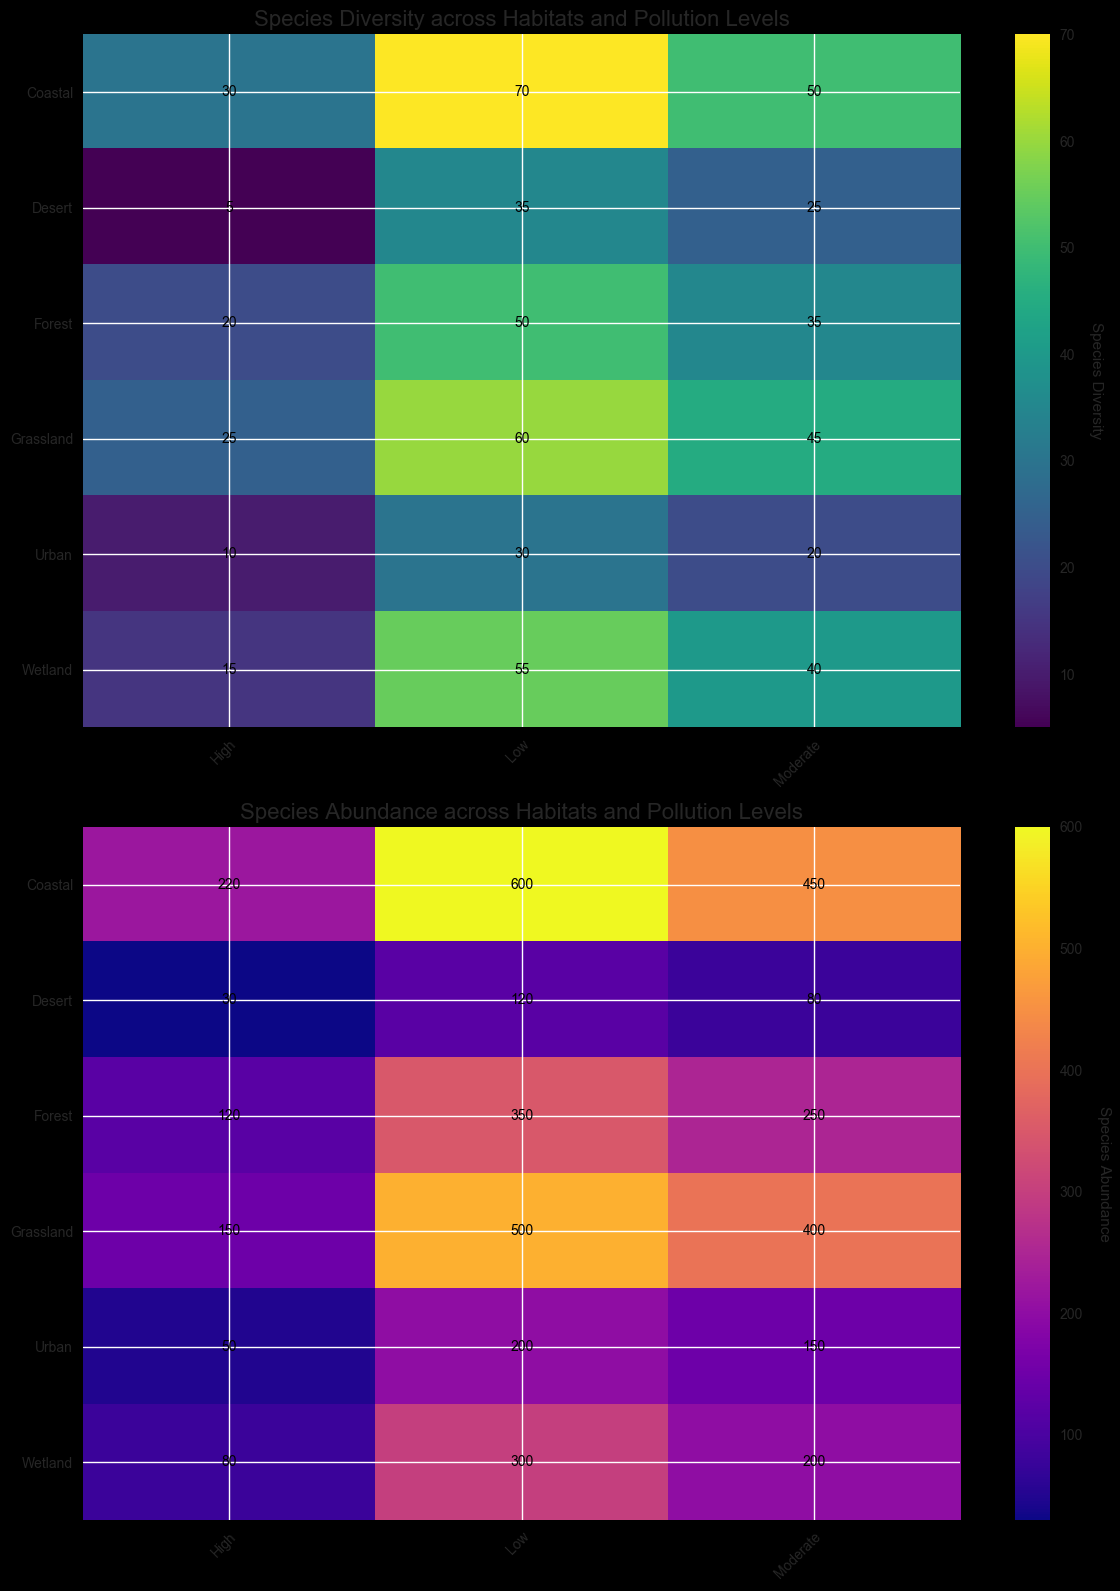What habitat has the highest species diversity at low pollution levels? Look at the first heatmap for species diversity, focusing on columns labeled 'Low'. The row labeled 'Coastal' has the darkest shade, indicating the highest number.
Answer: Coastal Which habitat shows the greatest decrease in species diversity from low to high pollution levels? Observe the difference in species diversity values from the 'Low' to 'High' columns. 'Desert' decreases from 35 to 5, a drop of 30.
Answer: Desert Compare the species abundance in grassland and wetlands at moderate pollution levels. Which one is higher? Check the second heatmap for species abundance. At 'Moderate' pollution levels, Grassland has a value of 400, while Wetland has 200.
Answer: Grassland What is the average species diversity for all habitats at moderate pollution levels? Add the species diversity values at 'Moderate' pollution levels for all habitats and divide by the number of habitats. (35 + 45 + 40 + 50 + 20 + 25) / 6 = 35.83
Answer: 35.83 How does species abundance in urban habitats change across different pollution levels? Look at the second heatmap, particularly at the 'Urban' row. Abundance values are 200 (Low), 150 (Moderate), and 50 (High).
Answer: Decreases In which habitat is species diversity least affected by pollution levels? Compare the difference between the 'Low' and 'High' columns for each habitat in the species diversity heatmap. 'Urban' changes from 30 to 10, a smallest change of 20.
Answer: Urban Which habitat has the lowest species abundance at high pollution levels? Check the values in the 'High' pollution level column of the species abundance heatmap. The 'Desert' has the lowest value of 30.
Answer: Desert Calculate the total species diversity for all habitats at low pollution levels. Add the species diversity values at 'Low' pollution levels for all habitats: 50 + 60 + 55 + 70 + 30 + 35 = 300.
Answer: 300 Is there a habitat where species abundance and diversity both remain relatively high even at moderate pollution levels? Look at both heatmaps for moderate pollution levels and compare values. 'Grassland' has relatively high values in both abundance (400) and diversity (45).
Answer: Grassland 